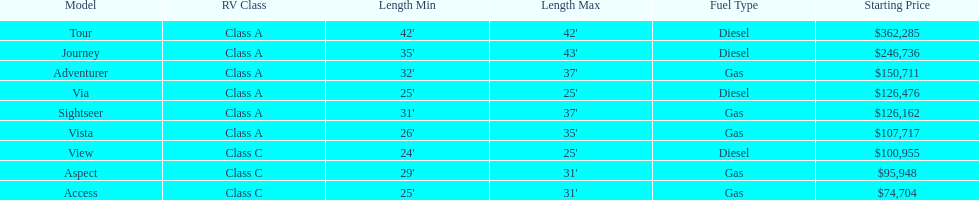What is the name of the top priced winnebago model? Tour. Parse the full table. {'header': ['Model', 'RV Class', 'Length Min', 'Length Max', 'Fuel Type', 'Starting Price'], 'rows': [['Tour', 'Class A', "42'", "42'", 'Diesel', '$362,285'], ['Journey', 'Class A', "35'", "43'", 'Diesel', '$246,736'], ['Adventurer', 'Class A', "32'", "37'", 'Gas', '$150,711'], ['Via', 'Class A', "25'", "25'", 'Diesel', '$126,476'], ['Sightseer', 'Class A', "31'", "37'", 'Gas', '$126,162'], ['Vista', 'Class A', "26'", "35'", 'Gas', '$107,717'], ['View', 'Class C', "24'", "25'", 'Diesel', '$100,955'], ['Aspect', 'Class C', "29'", "31'", 'Gas', '$95,948'], ['Access', 'Class C', "25'", "31'", 'Gas', '$74,704']]} 